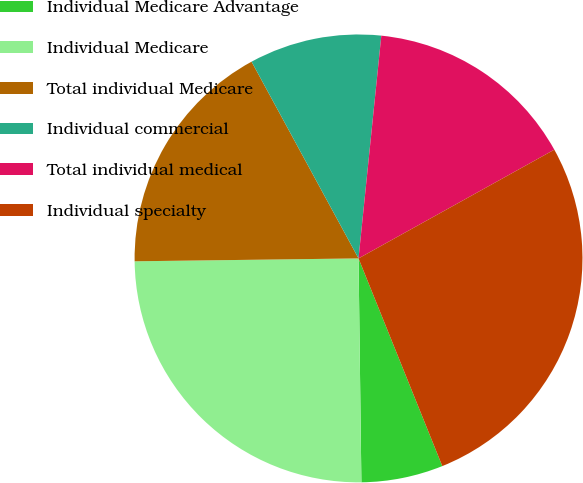<chart> <loc_0><loc_0><loc_500><loc_500><pie_chart><fcel>Individual Medicare Advantage<fcel>Individual Medicare<fcel>Total individual Medicare<fcel>Individual commercial<fcel>Total individual medical<fcel>Individual specialty<nl><fcel>5.9%<fcel>25.0%<fcel>17.28%<fcel>9.55%<fcel>15.31%<fcel>26.97%<nl></chart> 